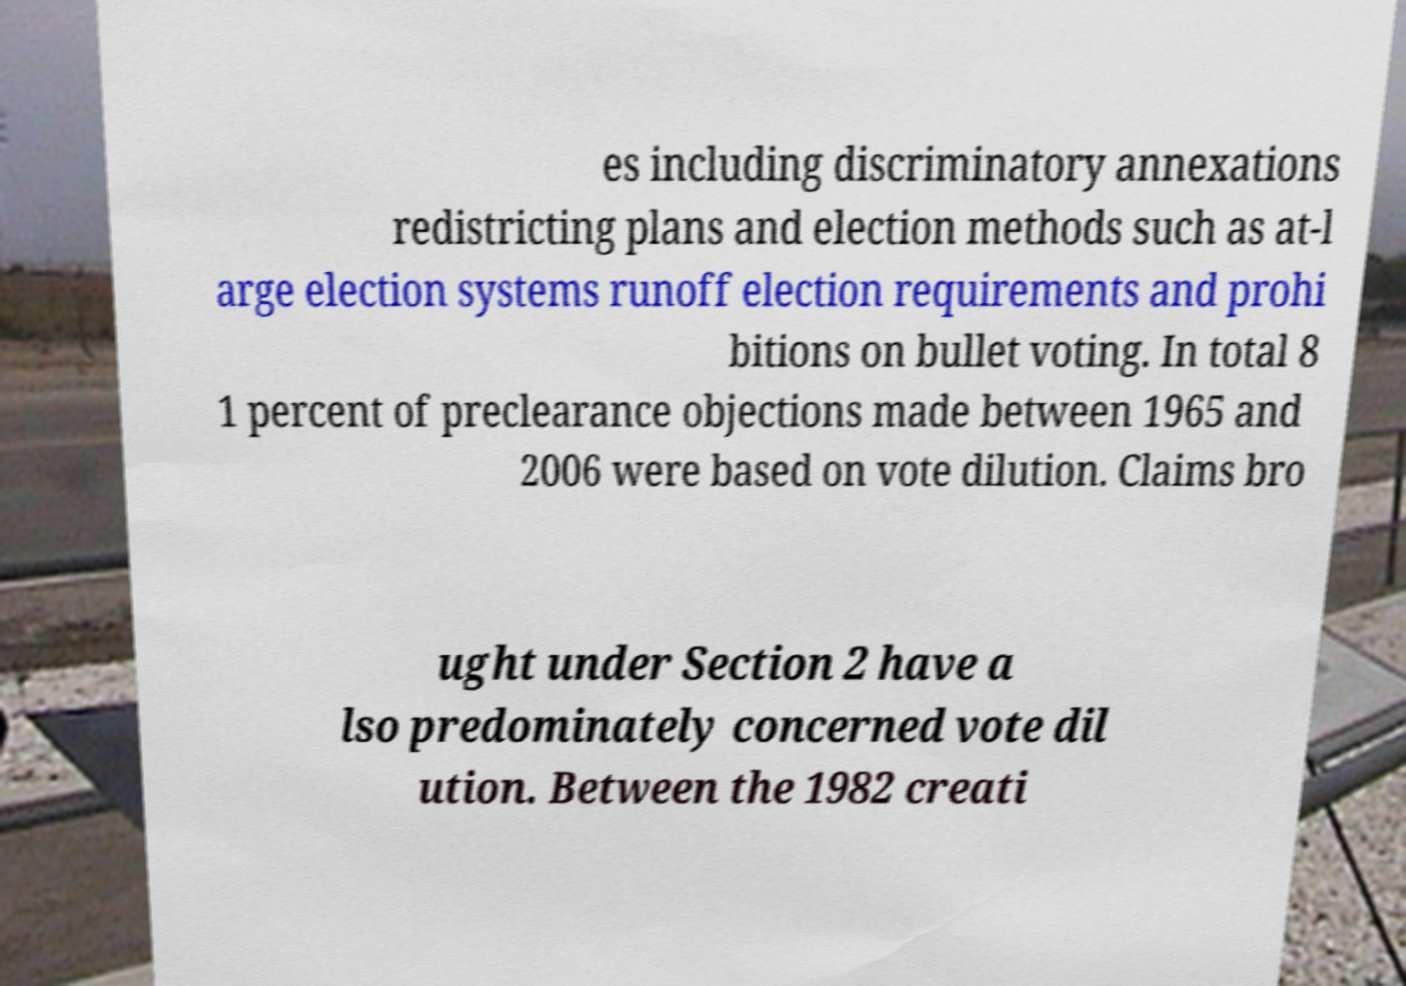What messages or text are displayed in this image? I need them in a readable, typed format. es including discriminatory annexations redistricting plans and election methods such as at-l arge election systems runoff election requirements and prohi bitions on bullet voting. In total 8 1 percent of preclearance objections made between 1965 and 2006 were based on vote dilution. Claims bro ught under Section 2 have a lso predominately concerned vote dil ution. Between the 1982 creati 